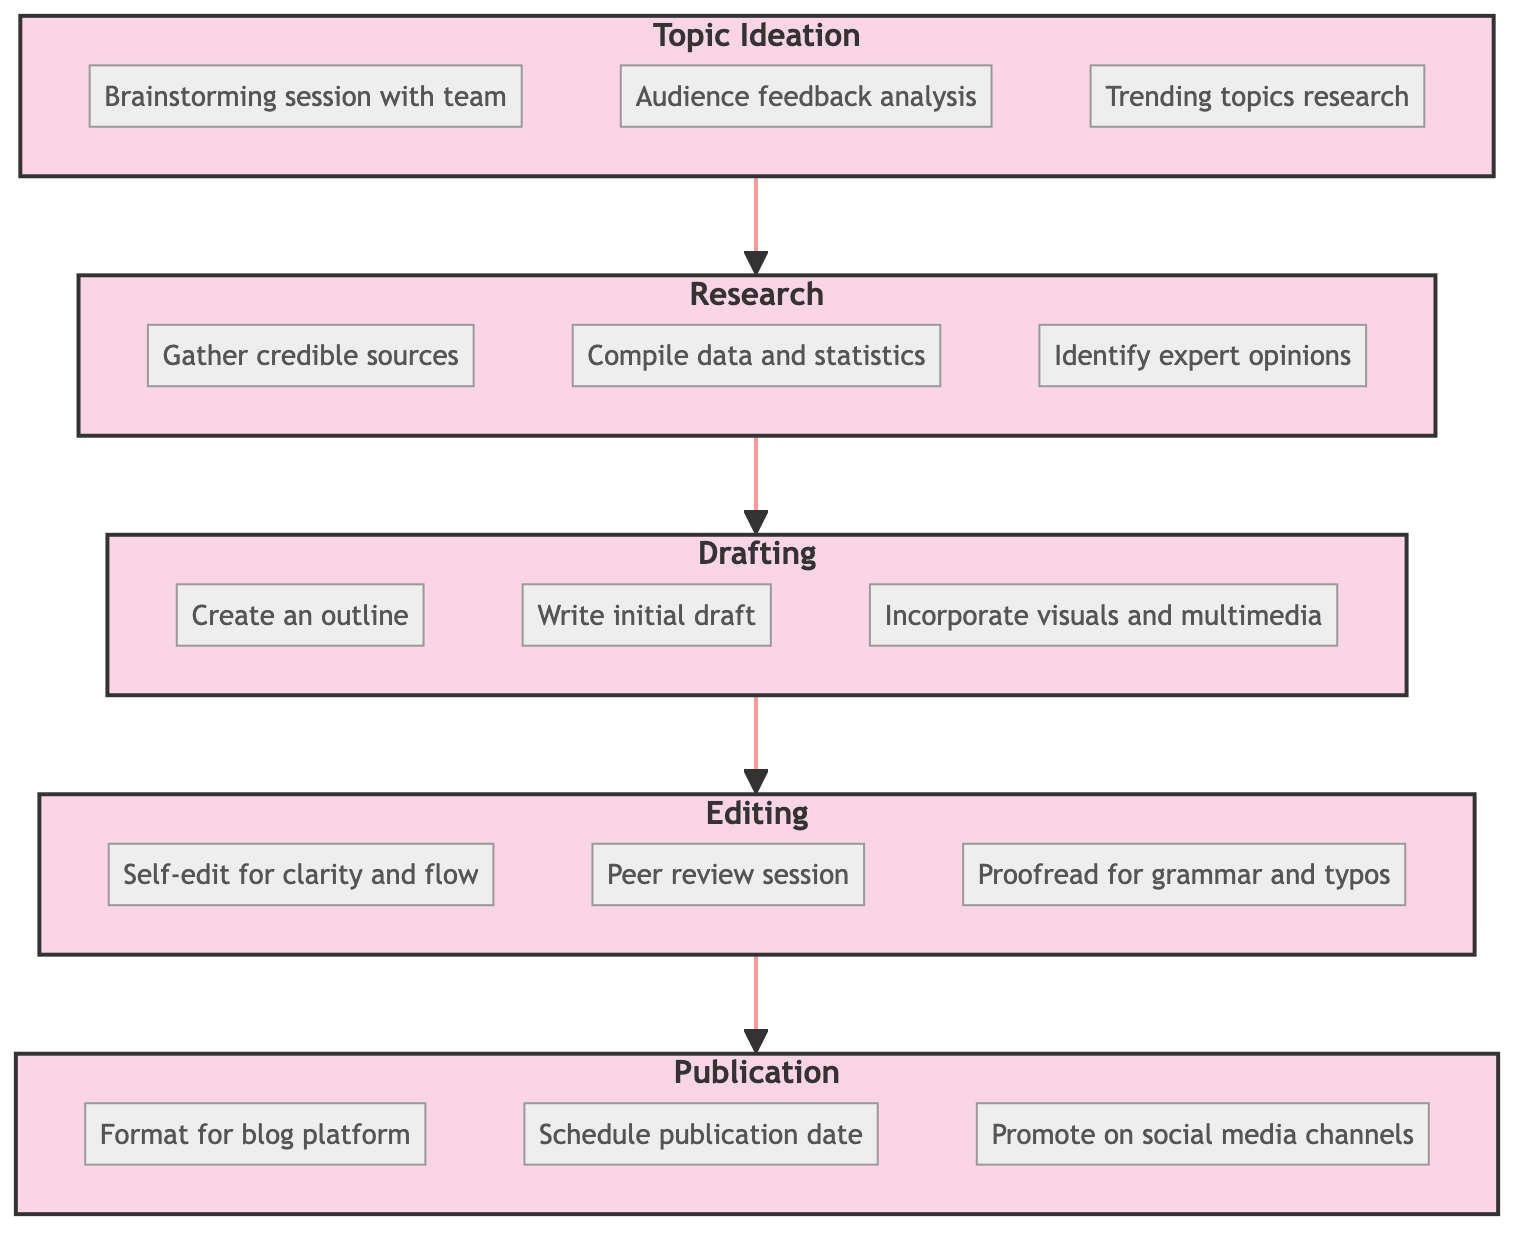What is the first stage in the workflow? The first stage listed in the workflow is "Topic Ideation," as it is the starting point of the flowchart that leads into the next stage.
Answer: Topic Ideation How many stages are there in total? The diagram has five distinct stages: Topic Ideation, Research, Drafting, Editing, and Publication, which cumulatively represent the entire workflow.
Answer: Five What follows the Research stage? The flowchart indicates that the stage that follows Research is Drafting, as it is connected directly by an arrow showing the progression of tasks.
Answer: Drafting What is one task involved in the Editing stage? From the diagram, "Proofread for grammar and typos" is one of the tasks listed under the Editing stage, illustrating a specific action taken during this phase.
Answer: Proofread for grammar and typos Name the last stage in the workflow. The last stage in the content creation workflow shown in the diagram is Publication, which is the endpoint of the flowchart and signifies the completion of the process.
Answer: Publication Which stage includes the task of "Write initial draft"? The task "Write initial draft" is included in the Drafting stage, as it specifies a core activity that occurs within that particular phase of the workflow.
Answer: Drafting What comes before the Editing stage? According to the flow, the stage that comes before Editing is Drafting, establishing a sequential order from content creation to the final edits.
Answer: Drafting How many tasks are listed under the Publication stage? The Publication stage encompasses three tasks: "Format for blog platform," "Schedule publication date," and "Promote on social media channels," indicating a focus on disseminating the content effectively.
Answer: Three 